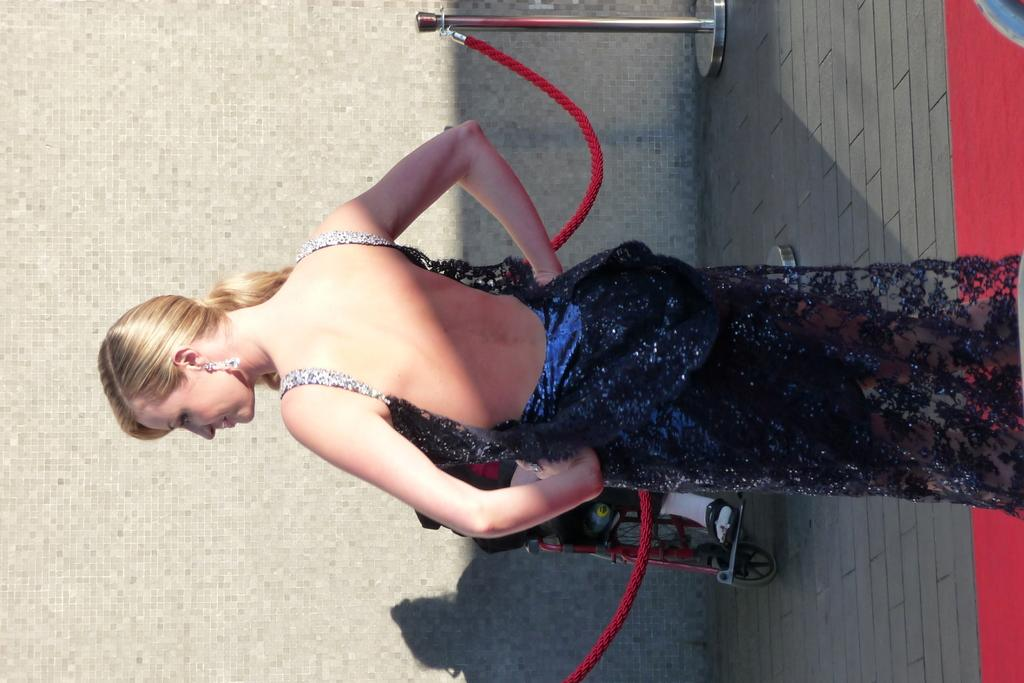Who is the main subject in the image? There is a woman in the image. What is the woman standing on? The woman is standing on a red carpet. What other objects can be seen in the image? There are ropes and stands visible in the image. Can you tell me how many donkeys are present in the image? There are no donkeys present in the image. What type of quartz can be seen on the woman's necklace in the image? There is no necklace or quartz visible in the image. 